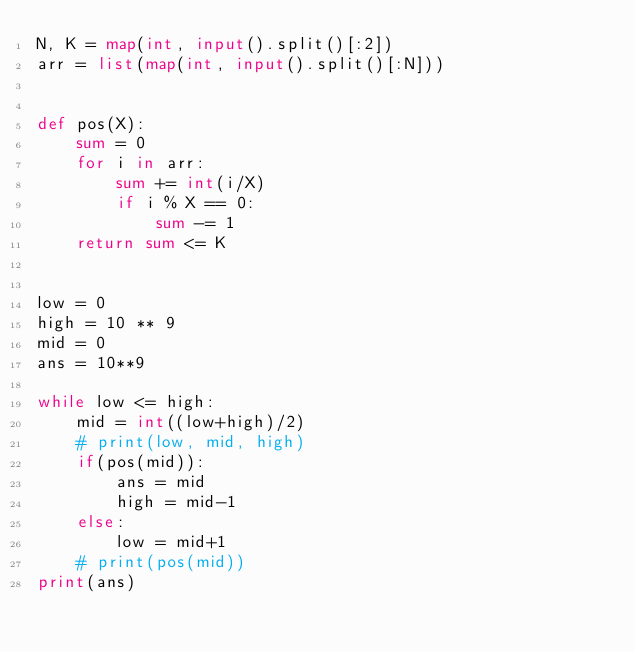Convert code to text. <code><loc_0><loc_0><loc_500><loc_500><_Python_>N, K = map(int, input().split()[:2])
arr = list(map(int, input().split()[:N]))


def pos(X):
    sum = 0
    for i in arr:
        sum += int(i/X)
        if i % X == 0:
            sum -= 1
    return sum <= K


low = 0
high = 10 ** 9
mid = 0
ans = 10**9

while low <= high:
    mid = int((low+high)/2)
    # print(low, mid, high)
    if(pos(mid)):
        ans = mid
        high = mid-1
    else:
        low = mid+1
    # print(pos(mid))
print(ans)
</code> 